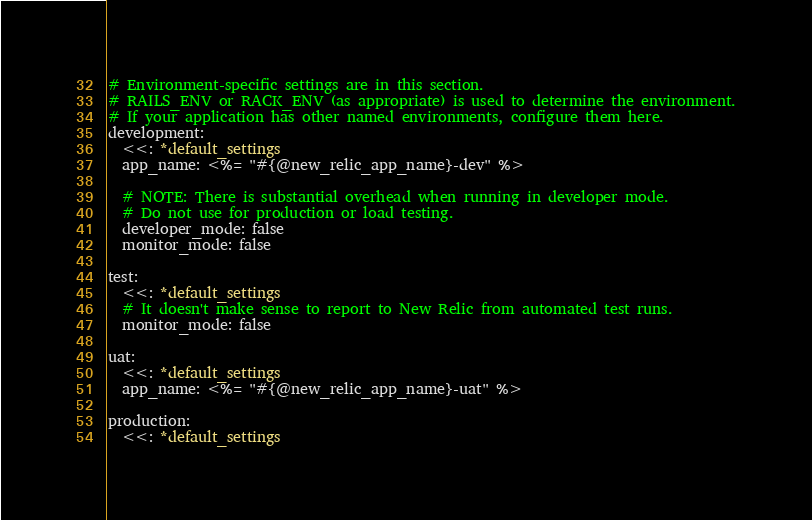<code> <loc_0><loc_0><loc_500><loc_500><_YAML_># Environment-specific settings are in this section.
# RAILS_ENV or RACK_ENV (as appropriate) is used to determine the environment.
# If your application has other named environments, configure them here.
development:
  <<: *default_settings
  app_name: <%= "#{@new_relic_app_name}-dev" %>

  # NOTE: There is substantial overhead when running in developer mode.
  # Do not use for production or load testing.
  developer_mode: false
  monitor_mode: false

test:
  <<: *default_settings
  # It doesn't make sense to report to New Relic from automated test runs.
  monitor_mode: false

uat:
  <<: *default_settings
  app_name: <%= "#{@new_relic_app_name}-uat" %>

production:
  <<: *default_settings
</code> 